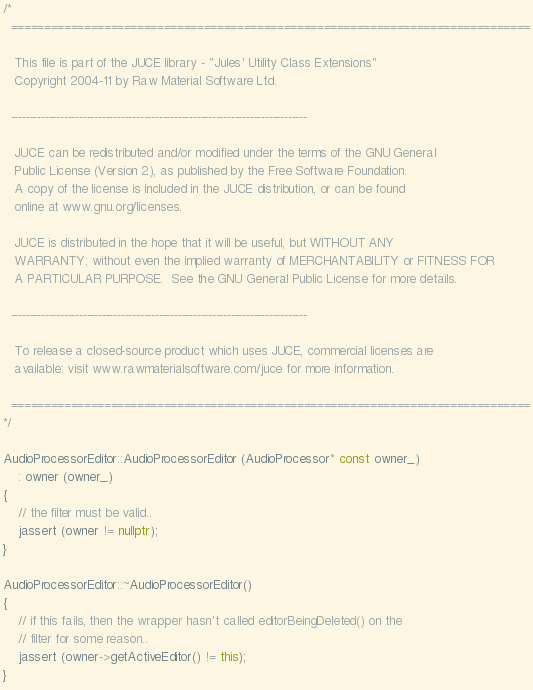Convert code to text. <code><loc_0><loc_0><loc_500><loc_500><_C++_>/*
  ==============================================================================

   This file is part of the JUCE library - "Jules' Utility Class Extensions"
   Copyright 2004-11 by Raw Material Software Ltd.

  ------------------------------------------------------------------------------

   JUCE can be redistributed and/or modified under the terms of the GNU General
   Public License (Version 2), as published by the Free Software Foundation.
   A copy of the license is included in the JUCE distribution, or can be found
   online at www.gnu.org/licenses.

   JUCE is distributed in the hope that it will be useful, but WITHOUT ANY
   WARRANTY; without even the implied warranty of MERCHANTABILITY or FITNESS FOR
   A PARTICULAR PURPOSE.  See the GNU General Public License for more details.

  ------------------------------------------------------------------------------

   To release a closed-source product which uses JUCE, commercial licenses are
   available: visit www.rawmaterialsoftware.com/juce for more information.

  ==============================================================================
*/

AudioProcessorEditor::AudioProcessorEditor (AudioProcessor* const owner_)
    : owner (owner_)
{
    // the filter must be valid..
    jassert (owner != nullptr);
}

AudioProcessorEditor::~AudioProcessorEditor()
{
    // if this fails, then the wrapper hasn't called editorBeingDeleted() on the
    // filter for some reason..
    jassert (owner->getActiveEditor() != this);
}
</code> 